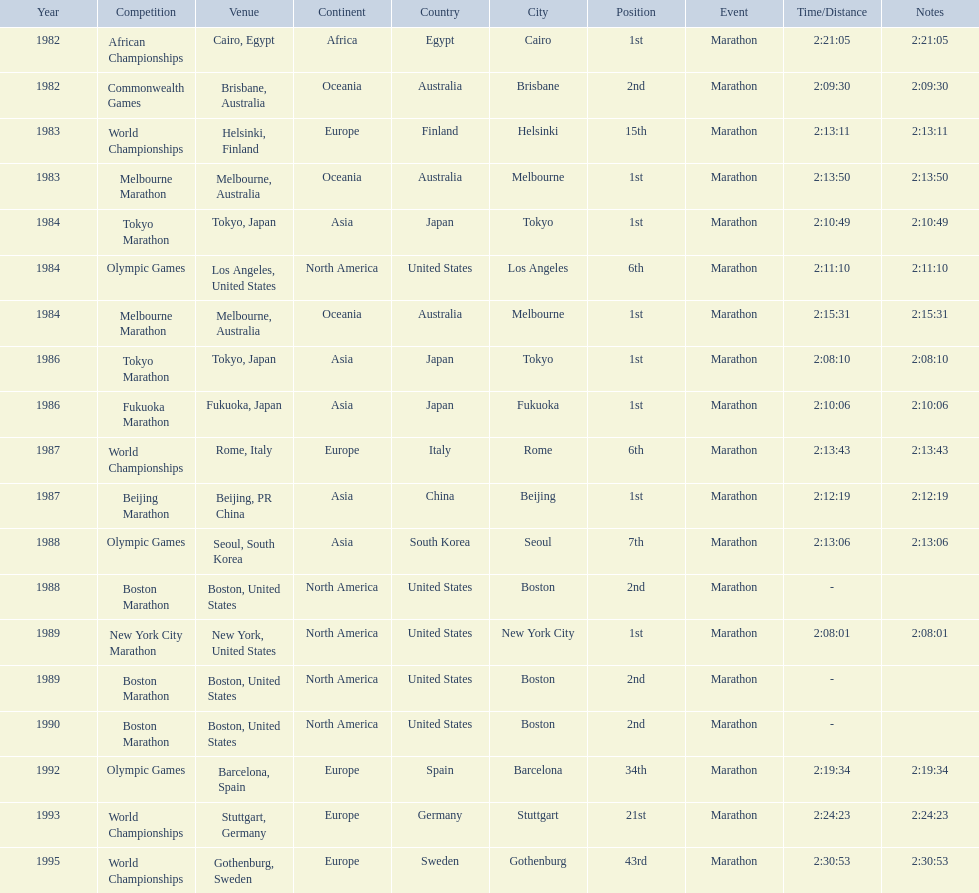What are the competitions? African Championships, Cairo, Egypt, Commonwealth Games, Brisbane, Australia, World Championships, Helsinki, Finland, Melbourne Marathon, Melbourne, Australia, Tokyo Marathon, Tokyo, Japan, Olympic Games, Los Angeles, United States, Melbourne Marathon, Melbourne, Australia, Tokyo Marathon, Tokyo, Japan, Fukuoka Marathon, Fukuoka, Japan, World Championships, Rome, Italy, Beijing Marathon, Beijing, PR China, Olympic Games, Seoul, South Korea, Boston Marathon, Boston, United States, New York City Marathon, New York, United States, Boston Marathon, Boston, United States, Boston Marathon, Boston, United States, Olympic Games, Barcelona, Spain, World Championships, Stuttgart, Germany, World Championships, Gothenburg, Sweden. Which ones occured in china? Beijing Marathon, Beijing, PR China. Which one is it? Beijing Marathon. 